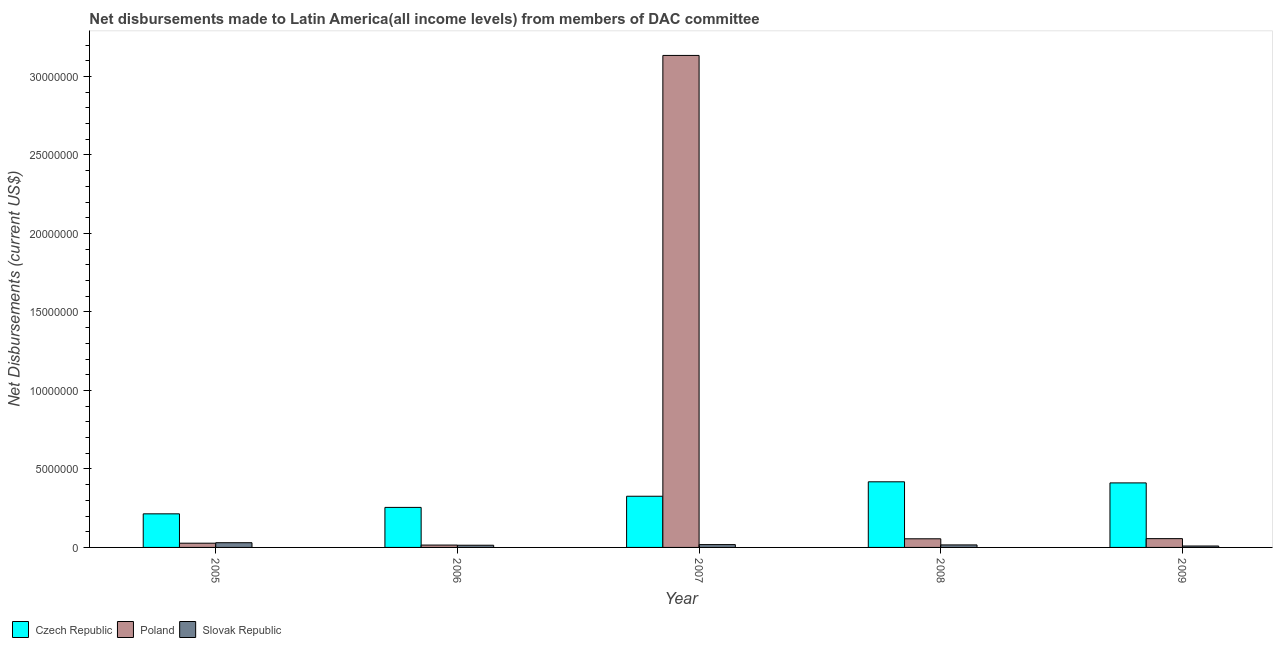How many different coloured bars are there?
Offer a terse response. 3. Are the number of bars per tick equal to the number of legend labels?
Provide a short and direct response. Yes. Are the number of bars on each tick of the X-axis equal?
Ensure brevity in your answer.  Yes. What is the net disbursements made by slovak republic in 2009?
Your response must be concise. 9.00e+04. Across all years, what is the maximum net disbursements made by czech republic?
Offer a terse response. 4.18e+06. Across all years, what is the minimum net disbursements made by czech republic?
Your answer should be very brief. 2.14e+06. What is the total net disbursements made by poland in the graph?
Make the answer very short. 3.29e+07. What is the difference between the net disbursements made by poland in 2005 and that in 2007?
Ensure brevity in your answer.  -3.11e+07. What is the difference between the net disbursements made by poland in 2008 and the net disbursements made by slovak republic in 2009?
Make the answer very short. -10000. What is the average net disbursements made by czech republic per year?
Ensure brevity in your answer.  3.25e+06. In the year 2006, what is the difference between the net disbursements made by slovak republic and net disbursements made by czech republic?
Provide a short and direct response. 0. In how many years, is the net disbursements made by slovak republic greater than 17000000 US$?
Make the answer very short. 0. What is the ratio of the net disbursements made by poland in 2007 to that in 2008?
Give a very brief answer. 56.98. What is the difference between the highest and the second highest net disbursements made by poland?
Offer a very short reply. 3.08e+07. What is the difference between the highest and the lowest net disbursements made by slovak republic?
Ensure brevity in your answer.  2.10e+05. Is the sum of the net disbursements made by slovak republic in 2005 and 2009 greater than the maximum net disbursements made by poland across all years?
Offer a very short reply. Yes. What does the 1st bar from the left in 2006 represents?
Make the answer very short. Czech Republic. What does the 1st bar from the right in 2006 represents?
Provide a succinct answer. Slovak Republic. What is the difference between two consecutive major ticks on the Y-axis?
Ensure brevity in your answer.  5.00e+06. Where does the legend appear in the graph?
Keep it short and to the point. Bottom left. How many legend labels are there?
Your answer should be compact. 3. What is the title of the graph?
Ensure brevity in your answer.  Net disbursements made to Latin America(all income levels) from members of DAC committee. What is the label or title of the X-axis?
Your response must be concise. Year. What is the label or title of the Y-axis?
Keep it short and to the point. Net Disbursements (current US$). What is the Net Disbursements (current US$) in Czech Republic in 2005?
Your answer should be compact. 2.14e+06. What is the Net Disbursements (current US$) in Poland in 2005?
Ensure brevity in your answer.  2.70e+05. What is the Net Disbursements (current US$) of Slovak Republic in 2005?
Ensure brevity in your answer.  3.00e+05. What is the Net Disbursements (current US$) of Czech Republic in 2006?
Keep it short and to the point. 2.55e+06. What is the Net Disbursements (current US$) in Poland in 2006?
Make the answer very short. 1.50e+05. What is the Net Disbursements (current US$) of Czech Republic in 2007?
Offer a terse response. 3.26e+06. What is the Net Disbursements (current US$) in Poland in 2007?
Provide a short and direct response. 3.13e+07. What is the Net Disbursements (current US$) of Slovak Republic in 2007?
Your answer should be very brief. 1.80e+05. What is the Net Disbursements (current US$) of Czech Republic in 2008?
Your answer should be compact. 4.18e+06. What is the Net Disbursements (current US$) in Slovak Republic in 2008?
Keep it short and to the point. 1.60e+05. What is the Net Disbursements (current US$) in Czech Republic in 2009?
Give a very brief answer. 4.11e+06. What is the Net Disbursements (current US$) of Poland in 2009?
Make the answer very short. 5.60e+05. What is the Net Disbursements (current US$) in Slovak Republic in 2009?
Provide a short and direct response. 9.00e+04. Across all years, what is the maximum Net Disbursements (current US$) of Czech Republic?
Make the answer very short. 4.18e+06. Across all years, what is the maximum Net Disbursements (current US$) in Poland?
Keep it short and to the point. 3.13e+07. Across all years, what is the minimum Net Disbursements (current US$) in Czech Republic?
Provide a succinct answer. 2.14e+06. Across all years, what is the minimum Net Disbursements (current US$) in Poland?
Provide a short and direct response. 1.50e+05. Across all years, what is the minimum Net Disbursements (current US$) in Slovak Republic?
Offer a very short reply. 9.00e+04. What is the total Net Disbursements (current US$) of Czech Republic in the graph?
Provide a succinct answer. 1.62e+07. What is the total Net Disbursements (current US$) in Poland in the graph?
Offer a very short reply. 3.29e+07. What is the total Net Disbursements (current US$) in Slovak Republic in the graph?
Provide a short and direct response. 8.70e+05. What is the difference between the Net Disbursements (current US$) of Czech Republic in 2005 and that in 2006?
Keep it short and to the point. -4.10e+05. What is the difference between the Net Disbursements (current US$) in Czech Republic in 2005 and that in 2007?
Make the answer very short. -1.12e+06. What is the difference between the Net Disbursements (current US$) in Poland in 2005 and that in 2007?
Keep it short and to the point. -3.11e+07. What is the difference between the Net Disbursements (current US$) of Slovak Republic in 2005 and that in 2007?
Make the answer very short. 1.20e+05. What is the difference between the Net Disbursements (current US$) of Czech Republic in 2005 and that in 2008?
Your answer should be compact. -2.04e+06. What is the difference between the Net Disbursements (current US$) of Poland in 2005 and that in 2008?
Ensure brevity in your answer.  -2.80e+05. What is the difference between the Net Disbursements (current US$) of Slovak Republic in 2005 and that in 2008?
Give a very brief answer. 1.40e+05. What is the difference between the Net Disbursements (current US$) in Czech Republic in 2005 and that in 2009?
Your answer should be very brief. -1.97e+06. What is the difference between the Net Disbursements (current US$) of Slovak Republic in 2005 and that in 2009?
Keep it short and to the point. 2.10e+05. What is the difference between the Net Disbursements (current US$) of Czech Republic in 2006 and that in 2007?
Provide a short and direct response. -7.10e+05. What is the difference between the Net Disbursements (current US$) in Poland in 2006 and that in 2007?
Ensure brevity in your answer.  -3.12e+07. What is the difference between the Net Disbursements (current US$) of Slovak Republic in 2006 and that in 2007?
Make the answer very short. -4.00e+04. What is the difference between the Net Disbursements (current US$) of Czech Republic in 2006 and that in 2008?
Ensure brevity in your answer.  -1.63e+06. What is the difference between the Net Disbursements (current US$) of Poland in 2006 and that in 2008?
Make the answer very short. -4.00e+05. What is the difference between the Net Disbursements (current US$) in Czech Republic in 2006 and that in 2009?
Keep it short and to the point. -1.56e+06. What is the difference between the Net Disbursements (current US$) of Poland in 2006 and that in 2009?
Make the answer very short. -4.10e+05. What is the difference between the Net Disbursements (current US$) in Czech Republic in 2007 and that in 2008?
Offer a very short reply. -9.20e+05. What is the difference between the Net Disbursements (current US$) of Poland in 2007 and that in 2008?
Keep it short and to the point. 3.08e+07. What is the difference between the Net Disbursements (current US$) in Czech Republic in 2007 and that in 2009?
Ensure brevity in your answer.  -8.50e+05. What is the difference between the Net Disbursements (current US$) in Poland in 2007 and that in 2009?
Your answer should be very brief. 3.08e+07. What is the difference between the Net Disbursements (current US$) of Czech Republic in 2008 and that in 2009?
Your answer should be very brief. 7.00e+04. What is the difference between the Net Disbursements (current US$) of Czech Republic in 2005 and the Net Disbursements (current US$) of Poland in 2006?
Give a very brief answer. 1.99e+06. What is the difference between the Net Disbursements (current US$) of Czech Republic in 2005 and the Net Disbursements (current US$) of Slovak Republic in 2006?
Your response must be concise. 2.00e+06. What is the difference between the Net Disbursements (current US$) of Poland in 2005 and the Net Disbursements (current US$) of Slovak Republic in 2006?
Offer a terse response. 1.30e+05. What is the difference between the Net Disbursements (current US$) in Czech Republic in 2005 and the Net Disbursements (current US$) in Poland in 2007?
Your answer should be compact. -2.92e+07. What is the difference between the Net Disbursements (current US$) in Czech Republic in 2005 and the Net Disbursements (current US$) in Slovak Republic in 2007?
Keep it short and to the point. 1.96e+06. What is the difference between the Net Disbursements (current US$) of Czech Republic in 2005 and the Net Disbursements (current US$) of Poland in 2008?
Ensure brevity in your answer.  1.59e+06. What is the difference between the Net Disbursements (current US$) of Czech Republic in 2005 and the Net Disbursements (current US$) of Slovak Republic in 2008?
Ensure brevity in your answer.  1.98e+06. What is the difference between the Net Disbursements (current US$) in Poland in 2005 and the Net Disbursements (current US$) in Slovak Republic in 2008?
Ensure brevity in your answer.  1.10e+05. What is the difference between the Net Disbursements (current US$) of Czech Republic in 2005 and the Net Disbursements (current US$) of Poland in 2009?
Keep it short and to the point. 1.58e+06. What is the difference between the Net Disbursements (current US$) of Czech Republic in 2005 and the Net Disbursements (current US$) of Slovak Republic in 2009?
Your response must be concise. 2.05e+06. What is the difference between the Net Disbursements (current US$) of Czech Republic in 2006 and the Net Disbursements (current US$) of Poland in 2007?
Make the answer very short. -2.88e+07. What is the difference between the Net Disbursements (current US$) in Czech Republic in 2006 and the Net Disbursements (current US$) in Slovak Republic in 2007?
Provide a succinct answer. 2.37e+06. What is the difference between the Net Disbursements (current US$) in Czech Republic in 2006 and the Net Disbursements (current US$) in Poland in 2008?
Offer a very short reply. 2.00e+06. What is the difference between the Net Disbursements (current US$) of Czech Republic in 2006 and the Net Disbursements (current US$) of Slovak Republic in 2008?
Give a very brief answer. 2.39e+06. What is the difference between the Net Disbursements (current US$) in Czech Republic in 2006 and the Net Disbursements (current US$) in Poland in 2009?
Make the answer very short. 1.99e+06. What is the difference between the Net Disbursements (current US$) in Czech Republic in 2006 and the Net Disbursements (current US$) in Slovak Republic in 2009?
Offer a very short reply. 2.46e+06. What is the difference between the Net Disbursements (current US$) of Czech Republic in 2007 and the Net Disbursements (current US$) of Poland in 2008?
Provide a succinct answer. 2.71e+06. What is the difference between the Net Disbursements (current US$) of Czech Republic in 2007 and the Net Disbursements (current US$) of Slovak Republic in 2008?
Give a very brief answer. 3.10e+06. What is the difference between the Net Disbursements (current US$) in Poland in 2007 and the Net Disbursements (current US$) in Slovak Republic in 2008?
Keep it short and to the point. 3.12e+07. What is the difference between the Net Disbursements (current US$) of Czech Republic in 2007 and the Net Disbursements (current US$) of Poland in 2009?
Your answer should be compact. 2.70e+06. What is the difference between the Net Disbursements (current US$) of Czech Republic in 2007 and the Net Disbursements (current US$) of Slovak Republic in 2009?
Keep it short and to the point. 3.17e+06. What is the difference between the Net Disbursements (current US$) of Poland in 2007 and the Net Disbursements (current US$) of Slovak Republic in 2009?
Offer a very short reply. 3.12e+07. What is the difference between the Net Disbursements (current US$) in Czech Republic in 2008 and the Net Disbursements (current US$) in Poland in 2009?
Keep it short and to the point. 3.62e+06. What is the difference between the Net Disbursements (current US$) of Czech Republic in 2008 and the Net Disbursements (current US$) of Slovak Republic in 2009?
Give a very brief answer. 4.09e+06. What is the difference between the Net Disbursements (current US$) in Poland in 2008 and the Net Disbursements (current US$) in Slovak Republic in 2009?
Offer a terse response. 4.60e+05. What is the average Net Disbursements (current US$) of Czech Republic per year?
Make the answer very short. 3.25e+06. What is the average Net Disbursements (current US$) of Poland per year?
Give a very brief answer. 6.57e+06. What is the average Net Disbursements (current US$) in Slovak Republic per year?
Your answer should be very brief. 1.74e+05. In the year 2005, what is the difference between the Net Disbursements (current US$) in Czech Republic and Net Disbursements (current US$) in Poland?
Provide a short and direct response. 1.87e+06. In the year 2005, what is the difference between the Net Disbursements (current US$) in Czech Republic and Net Disbursements (current US$) in Slovak Republic?
Give a very brief answer. 1.84e+06. In the year 2006, what is the difference between the Net Disbursements (current US$) in Czech Republic and Net Disbursements (current US$) in Poland?
Make the answer very short. 2.40e+06. In the year 2006, what is the difference between the Net Disbursements (current US$) of Czech Republic and Net Disbursements (current US$) of Slovak Republic?
Keep it short and to the point. 2.41e+06. In the year 2007, what is the difference between the Net Disbursements (current US$) in Czech Republic and Net Disbursements (current US$) in Poland?
Offer a very short reply. -2.81e+07. In the year 2007, what is the difference between the Net Disbursements (current US$) in Czech Republic and Net Disbursements (current US$) in Slovak Republic?
Your answer should be compact. 3.08e+06. In the year 2007, what is the difference between the Net Disbursements (current US$) in Poland and Net Disbursements (current US$) in Slovak Republic?
Offer a very short reply. 3.12e+07. In the year 2008, what is the difference between the Net Disbursements (current US$) in Czech Republic and Net Disbursements (current US$) in Poland?
Give a very brief answer. 3.63e+06. In the year 2008, what is the difference between the Net Disbursements (current US$) of Czech Republic and Net Disbursements (current US$) of Slovak Republic?
Keep it short and to the point. 4.02e+06. In the year 2008, what is the difference between the Net Disbursements (current US$) of Poland and Net Disbursements (current US$) of Slovak Republic?
Give a very brief answer. 3.90e+05. In the year 2009, what is the difference between the Net Disbursements (current US$) in Czech Republic and Net Disbursements (current US$) in Poland?
Provide a short and direct response. 3.55e+06. In the year 2009, what is the difference between the Net Disbursements (current US$) of Czech Republic and Net Disbursements (current US$) of Slovak Republic?
Your answer should be very brief. 4.02e+06. What is the ratio of the Net Disbursements (current US$) in Czech Republic in 2005 to that in 2006?
Make the answer very short. 0.84. What is the ratio of the Net Disbursements (current US$) in Slovak Republic in 2005 to that in 2006?
Make the answer very short. 2.14. What is the ratio of the Net Disbursements (current US$) in Czech Republic in 2005 to that in 2007?
Keep it short and to the point. 0.66. What is the ratio of the Net Disbursements (current US$) of Poland in 2005 to that in 2007?
Give a very brief answer. 0.01. What is the ratio of the Net Disbursements (current US$) of Czech Republic in 2005 to that in 2008?
Provide a succinct answer. 0.51. What is the ratio of the Net Disbursements (current US$) of Poland in 2005 to that in 2008?
Offer a terse response. 0.49. What is the ratio of the Net Disbursements (current US$) in Slovak Republic in 2005 to that in 2008?
Your response must be concise. 1.88. What is the ratio of the Net Disbursements (current US$) of Czech Republic in 2005 to that in 2009?
Offer a terse response. 0.52. What is the ratio of the Net Disbursements (current US$) in Poland in 2005 to that in 2009?
Your response must be concise. 0.48. What is the ratio of the Net Disbursements (current US$) of Slovak Republic in 2005 to that in 2009?
Make the answer very short. 3.33. What is the ratio of the Net Disbursements (current US$) of Czech Republic in 2006 to that in 2007?
Offer a terse response. 0.78. What is the ratio of the Net Disbursements (current US$) in Poland in 2006 to that in 2007?
Your answer should be very brief. 0. What is the ratio of the Net Disbursements (current US$) in Czech Republic in 2006 to that in 2008?
Keep it short and to the point. 0.61. What is the ratio of the Net Disbursements (current US$) in Poland in 2006 to that in 2008?
Your answer should be very brief. 0.27. What is the ratio of the Net Disbursements (current US$) in Czech Republic in 2006 to that in 2009?
Your answer should be compact. 0.62. What is the ratio of the Net Disbursements (current US$) of Poland in 2006 to that in 2009?
Your answer should be compact. 0.27. What is the ratio of the Net Disbursements (current US$) in Slovak Republic in 2006 to that in 2009?
Offer a very short reply. 1.56. What is the ratio of the Net Disbursements (current US$) of Czech Republic in 2007 to that in 2008?
Provide a succinct answer. 0.78. What is the ratio of the Net Disbursements (current US$) in Poland in 2007 to that in 2008?
Your answer should be very brief. 56.98. What is the ratio of the Net Disbursements (current US$) in Slovak Republic in 2007 to that in 2008?
Make the answer very short. 1.12. What is the ratio of the Net Disbursements (current US$) in Czech Republic in 2007 to that in 2009?
Your response must be concise. 0.79. What is the ratio of the Net Disbursements (current US$) of Poland in 2007 to that in 2009?
Your answer should be compact. 55.96. What is the ratio of the Net Disbursements (current US$) in Czech Republic in 2008 to that in 2009?
Your answer should be very brief. 1.02. What is the ratio of the Net Disbursements (current US$) in Poland in 2008 to that in 2009?
Your response must be concise. 0.98. What is the ratio of the Net Disbursements (current US$) in Slovak Republic in 2008 to that in 2009?
Make the answer very short. 1.78. What is the difference between the highest and the second highest Net Disbursements (current US$) of Czech Republic?
Your response must be concise. 7.00e+04. What is the difference between the highest and the second highest Net Disbursements (current US$) of Poland?
Your response must be concise. 3.08e+07. What is the difference between the highest and the lowest Net Disbursements (current US$) in Czech Republic?
Your answer should be compact. 2.04e+06. What is the difference between the highest and the lowest Net Disbursements (current US$) in Poland?
Provide a short and direct response. 3.12e+07. What is the difference between the highest and the lowest Net Disbursements (current US$) in Slovak Republic?
Offer a very short reply. 2.10e+05. 